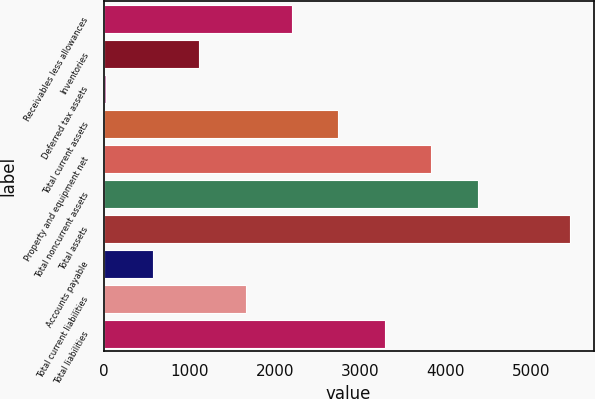Convert chart. <chart><loc_0><loc_0><loc_500><loc_500><bar_chart><fcel>Receivables less allowances<fcel>Inventories<fcel>Deferred tax assets<fcel>Total current assets<fcel>Property and equipment net<fcel>Total noncurrent assets<fcel>Total assets<fcel>Accounts payable<fcel>Total current liabilities<fcel>Total liabilities<nl><fcel>2200.6<fcel>1115.8<fcel>31<fcel>2743<fcel>3827.8<fcel>4370.2<fcel>5455<fcel>573.4<fcel>1658.2<fcel>3285.4<nl></chart> 